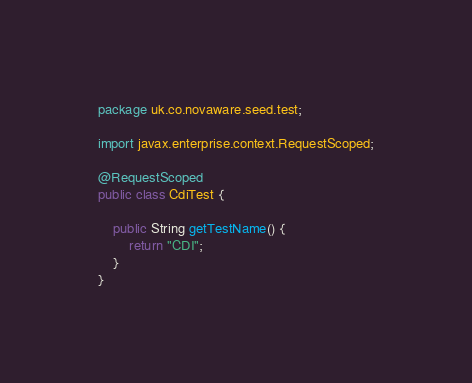Convert code to text. <code><loc_0><loc_0><loc_500><loc_500><_Java_>package uk.co.novaware.seed.test;

import javax.enterprise.context.RequestScoped;

@RequestScoped
public class CdiTest {

    public String getTestName() {
        return "CDI";
    }
}
</code> 